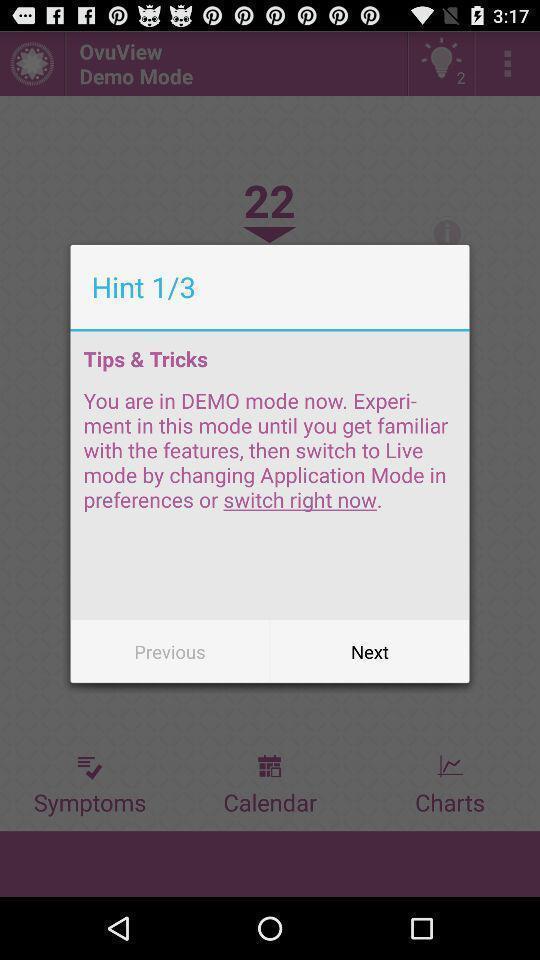Please provide a description for this image. Pop-up showing information about tips and tricks. 